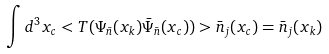Convert formula to latex. <formula><loc_0><loc_0><loc_500><loc_500>\int d ^ { 3 } x _ { c } < T ( \Psi _ { \bar { n } } ( x _ { k } ) \bar { \Psi } _ { \bar { n } } ( x _ { c } ) ) > \bar { n } _ { j } ( x _ { c } ) = \bar { n } _ { j } ( x _ { k } )</formula> 